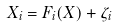<formula> <loc_0><loc_0><loc_500><loc_500>\dot { X _ { i } } = F _ { i } ( X ) + \zeta _ { i }</formula> 